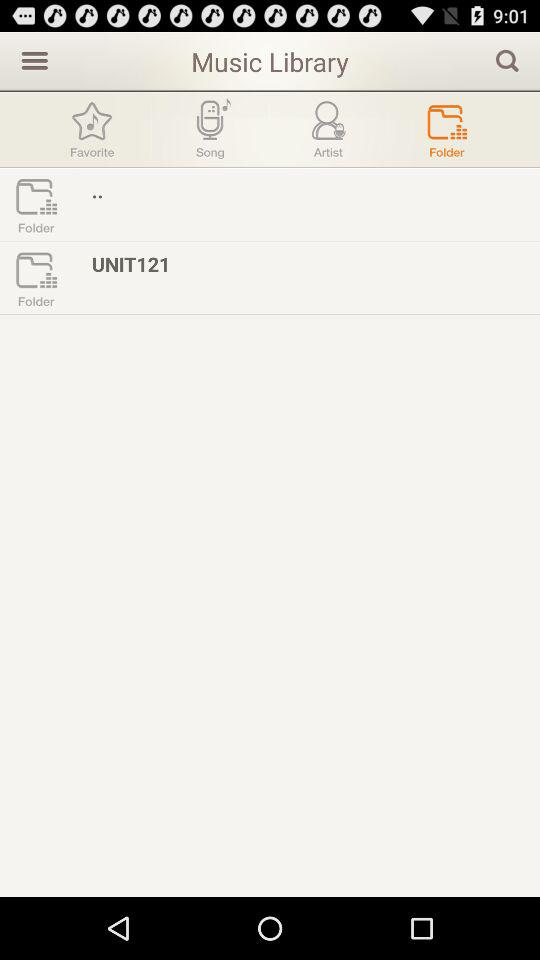Which tab is selected? The tab "Folder" is selected. 